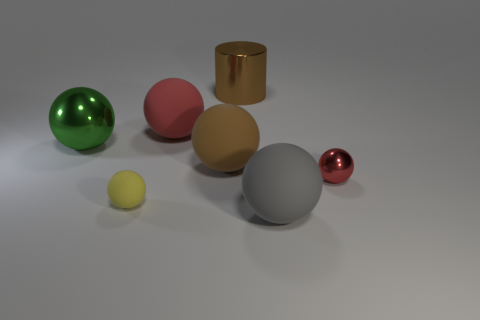What is the size of the rubber object that is behind the large brown matte ball?
Offer a very short reply. Large. How many green shiny spheres are on the left side of the large matte thing that is in front of the red metal ball?
Your answer should be compact. 1. There is a red object to the right of the large gray thing; does it have the same shape as the matte thing in front of the small matte object?
Offer a terse response. Yes. What number of metallic objects are both left of the big gray thing and in front of the brown cylinder?
Offer a very short reply. 1. Are there any other spheres that have the same color as the small metal ball?
Provide a short and direct response. Yes. What shape is the yellow matte thing that is the same size as the red metal object?
Make the answer very short. Sphere. Are there any matte balls to the right of the red shiny object?
Provide a short and direct response. No. Are the big ball in front of the red metallic ball and the big ball behind the large metallic sphere made of the same material?
Your answer should be very brief. Yes. What number of metal balls have the same size as the gray rubber sphere?
Your answer should be compact. 1. What is the shape of the matte object that is the same color as the tiny metallic object?
Your answer should be very brief. Sphere. 